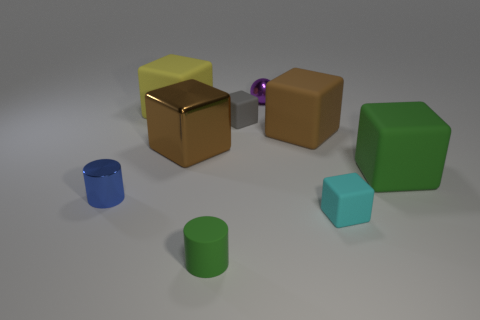Subtract all small gray rubber cubes. How many cubes are left? 5 Add 1 small yellow shiny cylinders. How many objects exist? 10 Subtract all blue cylinders. How many cylinders are left? 1 Subtract all gray balls. How many brown blocks are left? 2 Subtract all blocks. How many objects are left? 3 Subtract 1 cylinders. How many cylinders are left? 1 Subtract all green cylinders. Subtract all gray balls. How many cylinders are left? 1 Subtract all big cubes. Subtract all small cyan matte blocks. How many objects are left? 4 Add 6 green blocks. How many green blocks are left? 7 Add 4 purple metallic things. How many purple metallic things exist? 5 